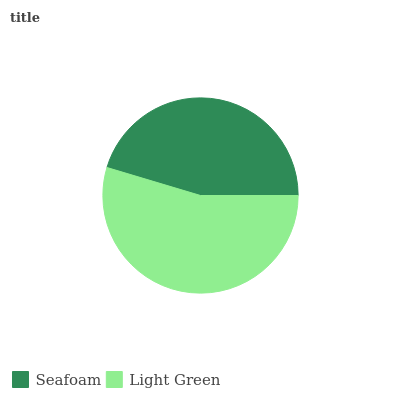Is Seafoam the minimum?
Answer yes or no. Yes. Is Light Green the maximum?
Answer yes or no. Yes. Is Light Green the minimum?
Answer yes or no. No. Is Light Green greater than Seafoam?
Answer yes or no. Yes. Is Seafoam less than Light Green?
Answer yes or no. Yes. Is Seafoam greater than Light Green?
Answer yes or no. No. Is Light Green less than Seafoam?
Answer yes or no. No. Is Light Green the high median?
Answer yes or no. Yes. Is Seafoam the low median?
Answer yes or no. Yes. Is Seafoam the high median?
Answer yes or no. No. Is Light Green the low median?
Answer yes or no. No. 